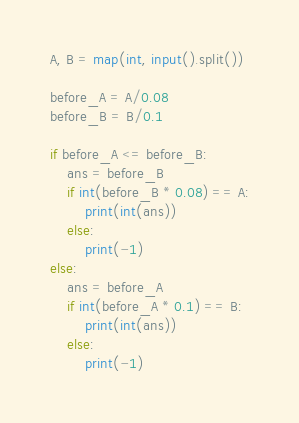<code> <loc_0><loc_0><loc_500><loc_500><_Python_>A, B = map(int, input().split())

before_A = A/0.08
before_B = B/0.1

if before_A <= before_B:
    ans = before_B
    if int(before_B * 0.08) == A:
        print(int(ans))
    else:
        print(-1)
else:
    ans = before_A
    if int(before_A * 0.1) == B:
        print(int(ans))
    else:
        print(-1)</code> 